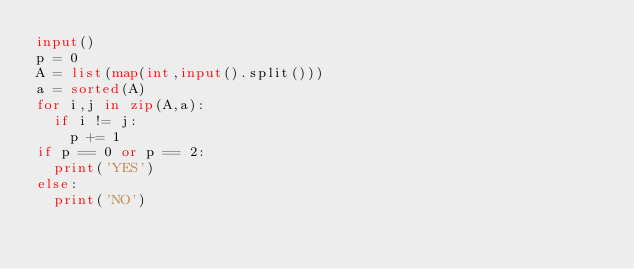Convert code to text. <code><loc_0><loc_0><loc_500><loc_500><_Python_>input()
p = 0
A = list(map(int,input().split()))
a = sorted(A)
for i,j in zip(A,a):
  if i != j:
    p += 1
if p == 0 or p == 2:
  print('YES')
else:
  print('NO')</code> 